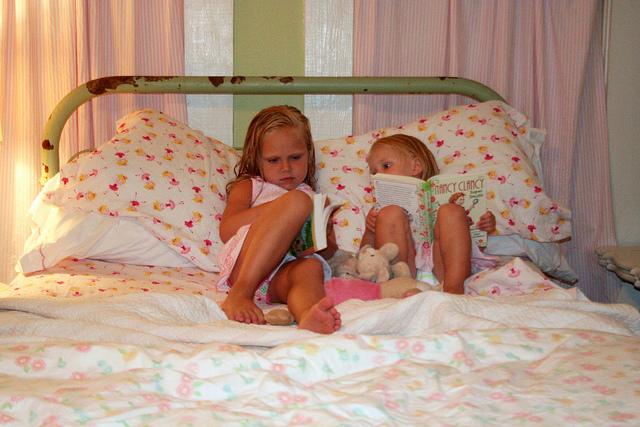Is this the kids bedroom?
Give a very brief answer. Yes. Where are the kids?
Write a very short answer. Bed. Are these girls or boys?
Concise answer only. Girls. What is the pattern on the sheets?
Quick response, please. Flowers. 